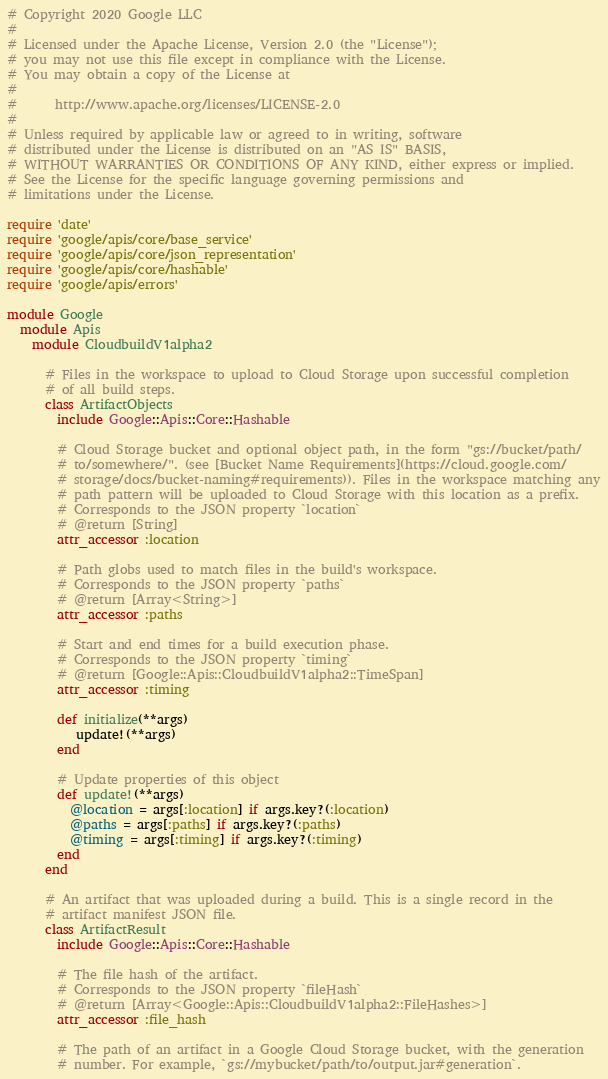Convert code to text. <code><loc_0><loc_0><loc_500><loc_500><_Ruby_># Copyright 2020 Google LLC
#
# Licensed under the Apache License, Version 2.0 (the "License");
# you may not use this file except in compliance with the License.
# You may obtain a copy of the License at
#
#      http://www.apache.org/licenses/LICENSE-2.0
#
# Unless required by applicable law or agreed to in writing, software
# distributed under the License is distributed on an "AS IS" BASIS,
# WITHOUT WARRANTIES OR CONDITIONS OF ANY KIND, either express or implied.
# See the License for the specific language governing permissions and
# limitations under the License.

require 'date'
require 'google/apis/core/base_service'
require 'google/apis/core/json_representation'
require 'google/apis/core/hashable'
require 'google/apis/errors'

module Google
  module Apis
    module CloudbuildV1alpha2
      
      # Files in the workspace to upload to Cloud Storage upon successful completion
      # of all build steps.
      class ArtifactObjects
        include Google::Apis::Core::Hashable
      
        # Cloud Storage bucket and optional object path, in the form "gs://bucket/path/
        # to/somewhere/". (see [Bucket Name Requirements](https://cloud.google.com/
        # storage/docs/bucket-naming#requirements)). Files in the workspace matching any
        # path pattern will be uploaded to Cloud Storage with this location as a prefix.
        # Corresponds to the JSON property `location`
        # @return [String]
        attr_accessor :location
      
        # Path globs used to match files in the build's workspace.
        # Corresponds to the JSON property `paths`
        # @return [Array<String>]
        attr_accessor :paths
      
        # Start and end times for a build execution phase.
        # Corresponds to the JSON property `timing`
        # @return [Google::Apis::CloudbuildV1alpha2::TimeSpan]
        attr_accessor :timing
      
        def initialize(**args)
           update!(**args)
        end
      
        # Update properties of this object
        def update!(**args)
          @location = args[:location] if args.key?(:location)
          @paths = args[:paths] if args.key?(:paths)
          @timing = args[:timing] if args.key?(:timing)
        end
      end
      
      # An artifact that was uploaded during a build. This is a single record in the
      # artifact manifest JSON file.
      class ArtifactResult
        include Google::Apis::Core::Hashable
      
        # The file hash of the artifact.
        # Corresponds to the JSON property `fileHash`
        # @return [Array<Google::Apis::CloudbuildV1alpha2::FileHashes>]
        attr_accessor :file_hash
      
        # The path of an artifact in a Google Cloud Storage bucket, with the generation
        # number. For example, `gs://mybucket/path/to/output.jar#generation`.</code> 